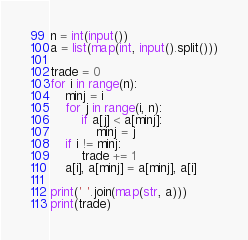Convert code to text. <code><loc_0><loc_0><loc_500><loc_500><_Python_>n = int(input())
a = list(map(int, input().split()))

trade = 0
for i in range(n):
    minj = i 
    for j in range(i, n):
        if a[j] < a[minj]:
            minj = j
    if i != minj:
        trade += 1
    a[i], a[minj] = a[minj], a[i]
    
print(' '.join(map(str, a)))
print(trade)
</code> 